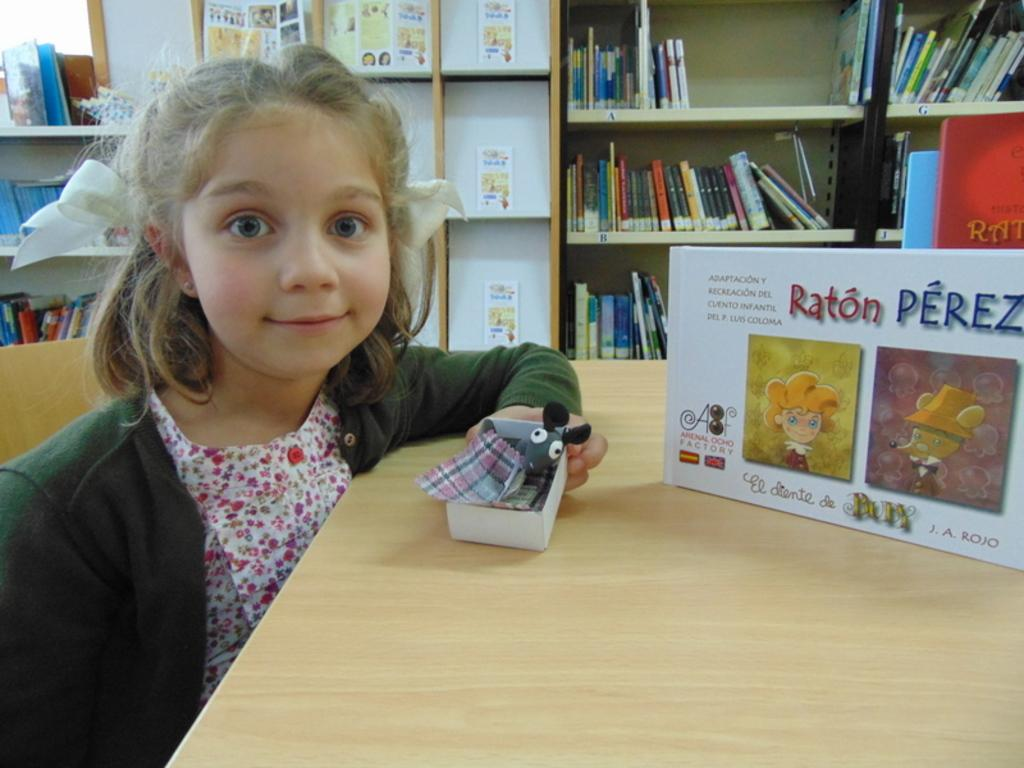<image>
Offer a succinct explanation of the picture presented. A girl holds a toy at a table next to a box of Raton Perez. 